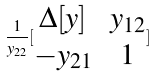Convert formula to latex. <formula><loc_0><loc_0><loc_500><loc_500>\frac { 1 } { y _ { 2 2 } } [ \begin{matrix} \Delta [ y ] & y _ { 1 2 } \\ - y _ { 2 1 } & 1 \end{matrix} ]</formula> 